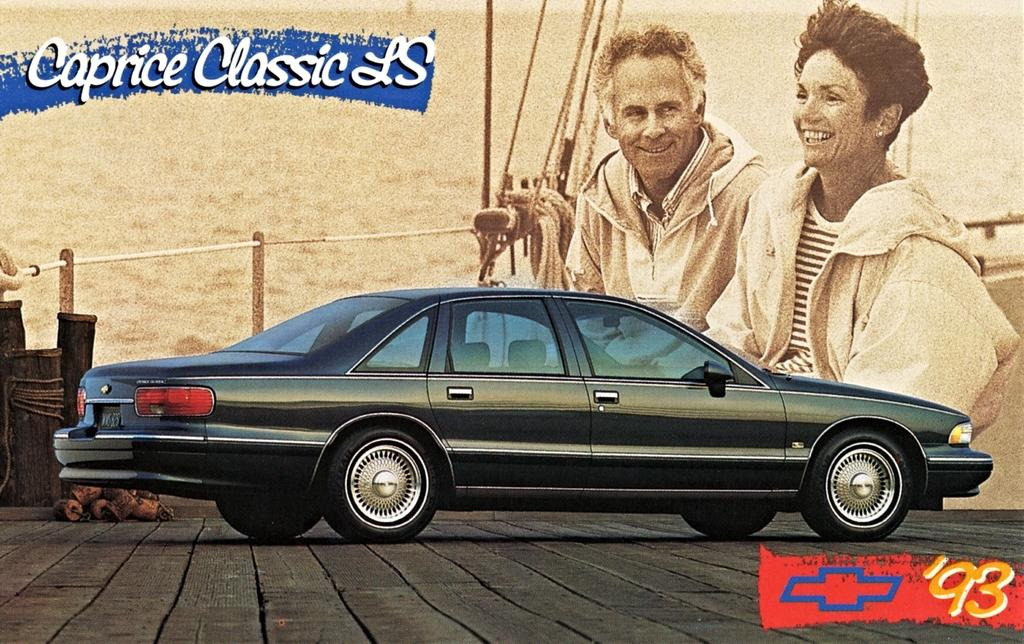What is the main subject of the image? There is a car in the image. What can be seen in the background of the image? There is a poster in the background of the image. What is depicted on the poster? The poster features a man and a woman. What expression do the man and woman on the poster have? The man and woman on the poster are smiling. What type of rhythm can be heard coming from the car in the image? There is no indication of sound or rhythm in the image, as it features a car and a poster with a man and a woman. 